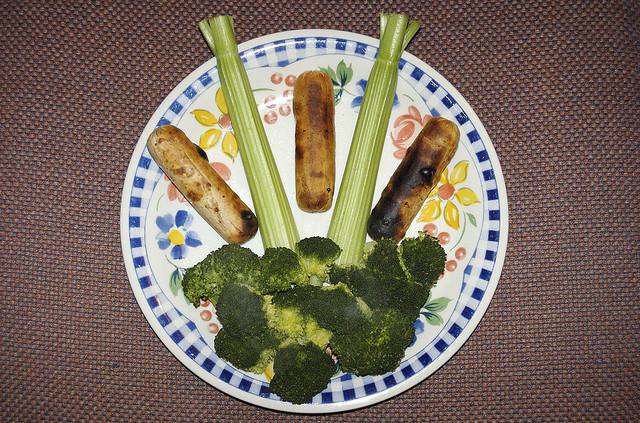What are the two long green sticks?
Concise answer only. Celery. What design is on the plate?
Answer briefly. Frog. Where are the broccolis?
Give a very brief answer. Bottom of plate. 